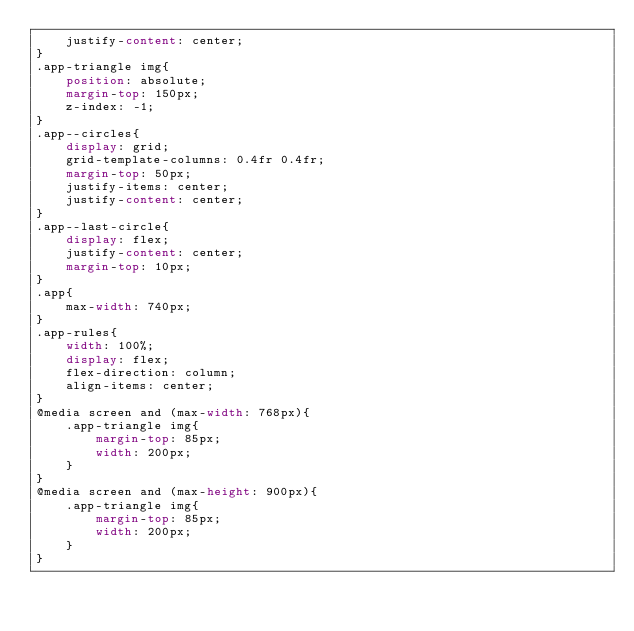Convert code to text. <code><loc_0><loc_0><loc_500><loc_500><_CSS_>    justify-content: center;
}
.app-triangle img{
    position: absolute;
    margin-top: 150px;
    z-index: -1;
}
.app--circles{
    display: grid;
    grid-template-columns: 0.4fr 0.4fr;
    margin-top: 50px;
    justify-items: center;
    justify-content: center;
}
.app--last-circle{
    display: flex;
    justify-content: center;
    margin-top: 10px;
}
.app{
    max-width: 740px;
}
.app-rules{ 
    width: 100%;
    display: flex;
    flex-direction: column;
    align-items: center;
}
@media screen and (max-width: 768px){
    .app-triangle img{
        margin-top: 85px;
        width: 200px;
    }
}
@media screen and (max-height: 900px){
    .app-triangle img{
        margin-top: 85px;
        width: 200px;
    }
}
</code> 